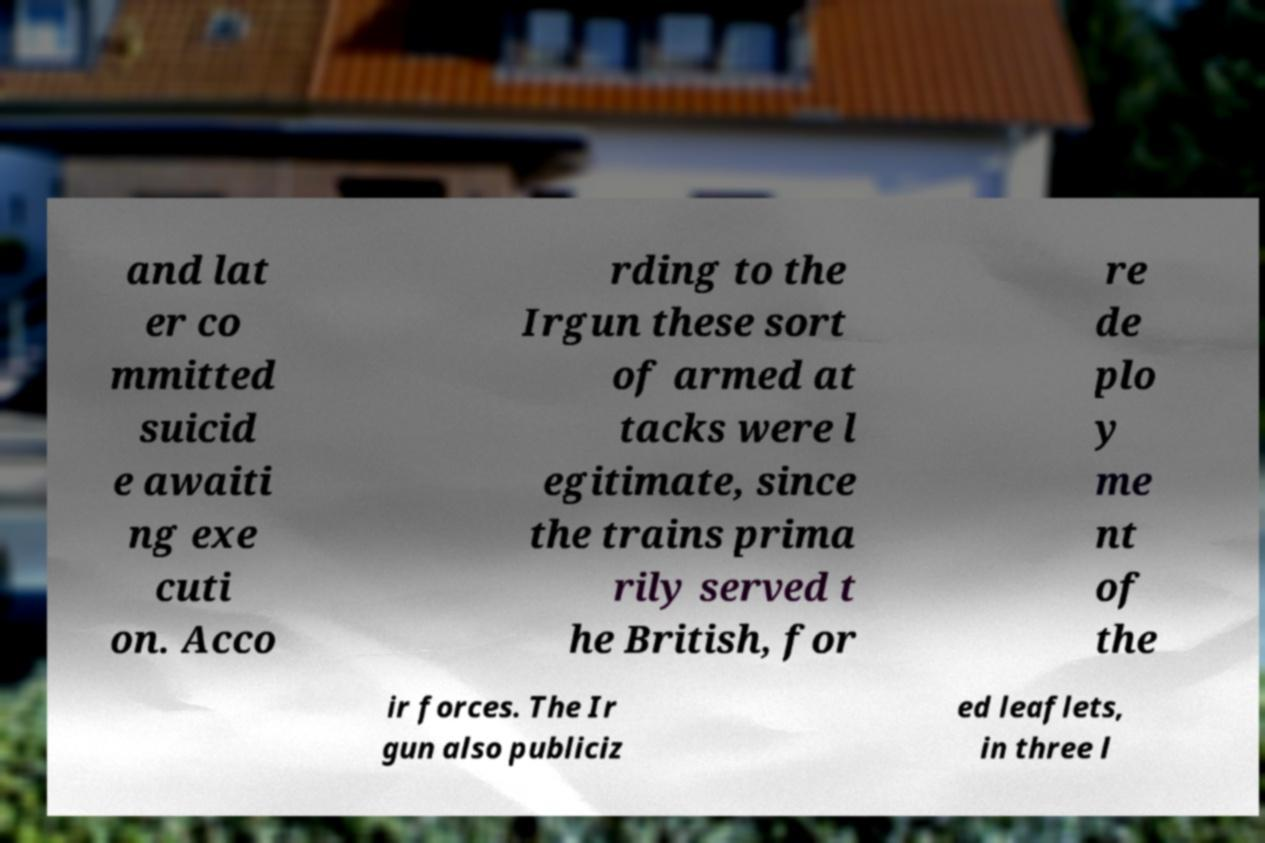Please identify and transcribe the text found in this image. and lat er co mmitted suicid e awaiti ng exe cuti on. Acco rding to the Irgun these sort of armed at tacks were l egitimate, since the trains prima rily served t he British, for re de plo y me nt of the ir forces. The Ir gun also publiciz ed leaflets, in three l 